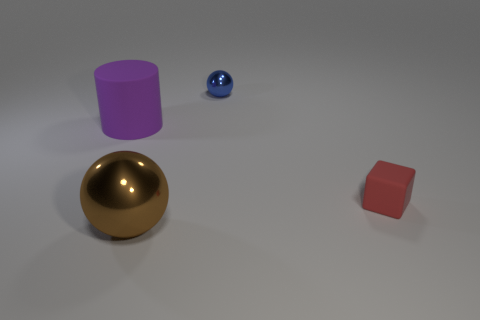Can you describe the lighting and shadow effects in the scene? The image shows soft, diffused lighting casting gentle shadows. Objects cast shadows mostly to the right, indicating a light source to the top left of the scene. The golden sphere reflects light strongly, suggesting it has a glossy surface, while the other objects have more subdued reflections. 